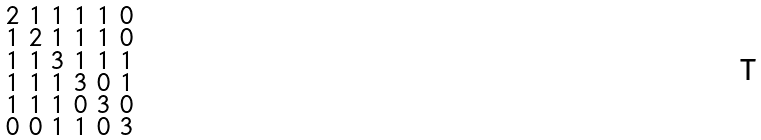Convert formula to latex. <formula><loc_0><loc_0><loc_500><loc_500>\begin{smallmatrix} 2 & 1 & 1 & 1 & 1 & 0 \\ 1 & 2 & 1 & 1 & 1 & 0 \\ 1 & 1 & 3 & 1 & 1 & 1 \\ 1 & 1 & 1 & 3 & 0 & 1 \\ 1 & 1 & 1 & 0 & 3 & 0 \\ 0 & 0 & 1 & 1 & 0 & 3 \end{smallmatrix}</formula> 